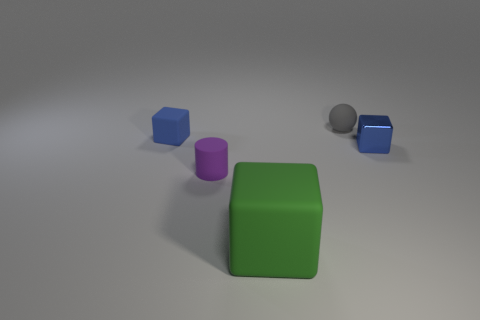Add 2 small cyan metallic things. How many objects exist? 7 Subtract all spheres. How many objects are left? 4 Add 1 tiny gray matte spheres. How many tiny gray matte spheres exist? 2 Subtract 0 purple balls. How many objects are left? 5 Subtract all green metallic cubes. Subtract all metallic things. How many objects are left? 4 Add 3 tiny shiny cubes. How many tiny shiny cubes are left? 4 